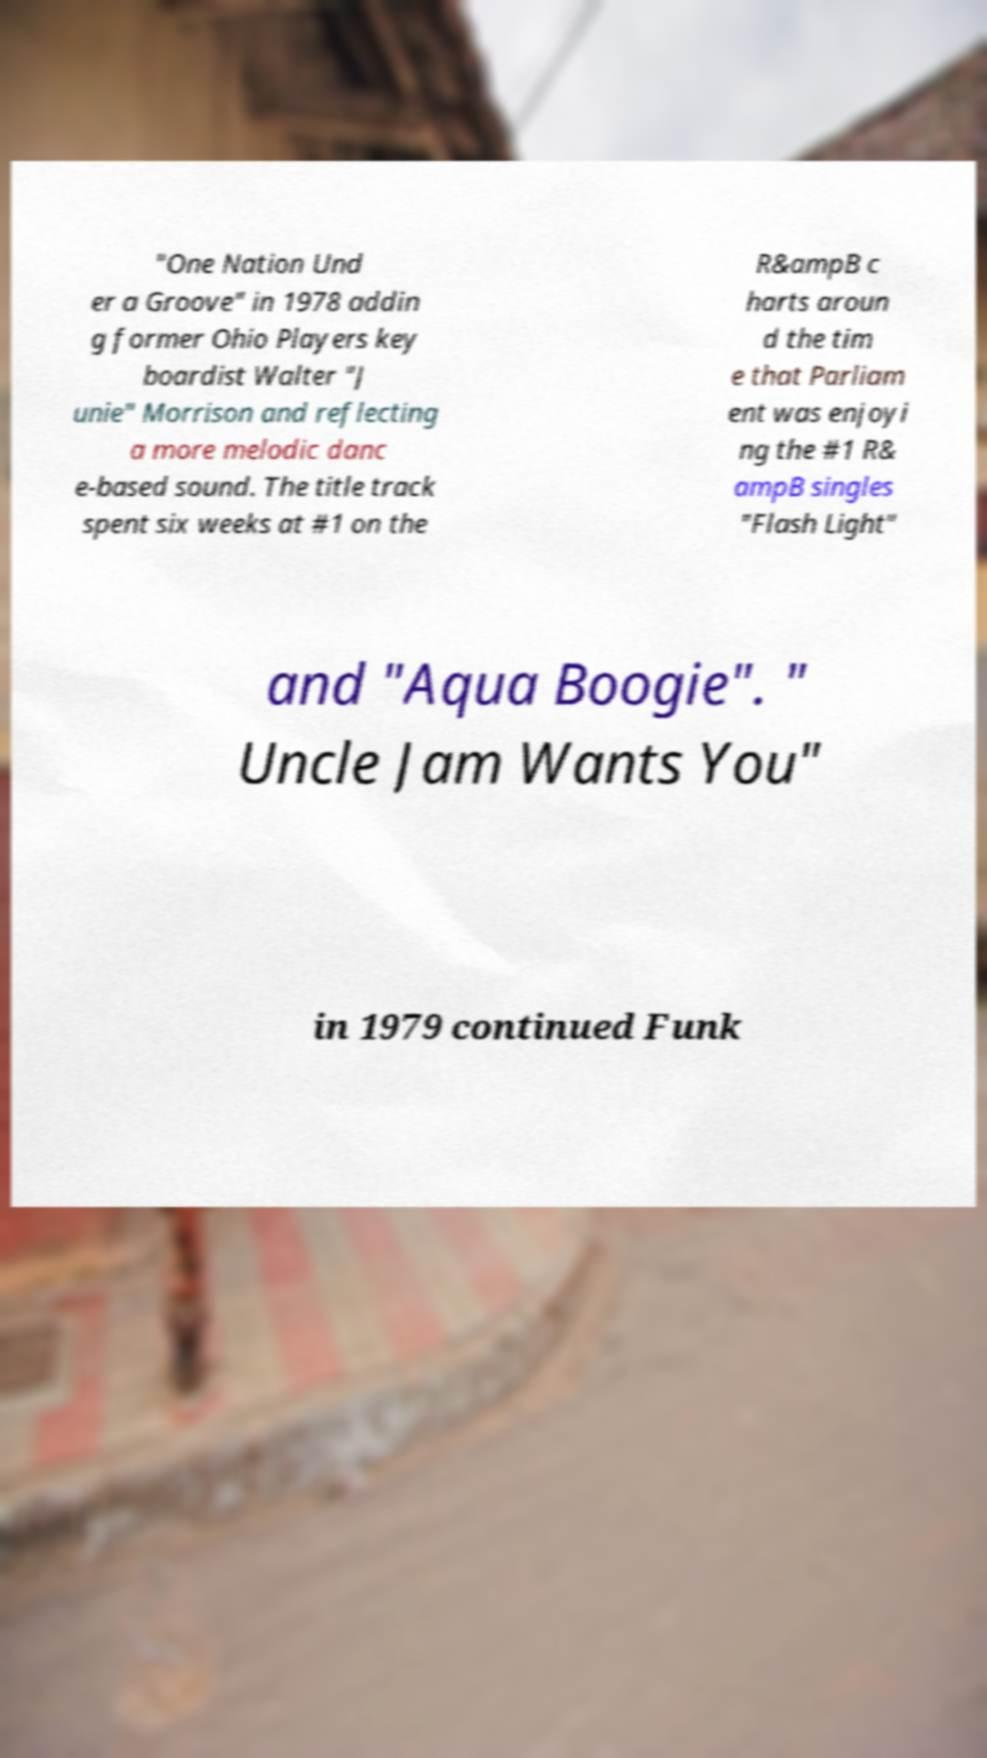Could you assist in decoding the text presented in this image and type it out clearly? "One Nation Und er a Groove" in 1978 addin g former Ohio Players key boardist Walter "J unie" Morrison and reflecting a more melodic danc e-based sound. The title track spent six weeks at #1 on the R&ampB c harts aroun d the tim e that Parliam ent was enjoyi ng the #1 R& ampB singles "Flash Light" and "Aqua Boogie". " Uncle Jam Wants You" in 1979 continued Funk 